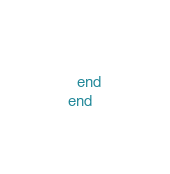Convert code to text. <code><loc_0><loc_0><loc_500><loc_500><_Ruby_>  end
end
</code> 